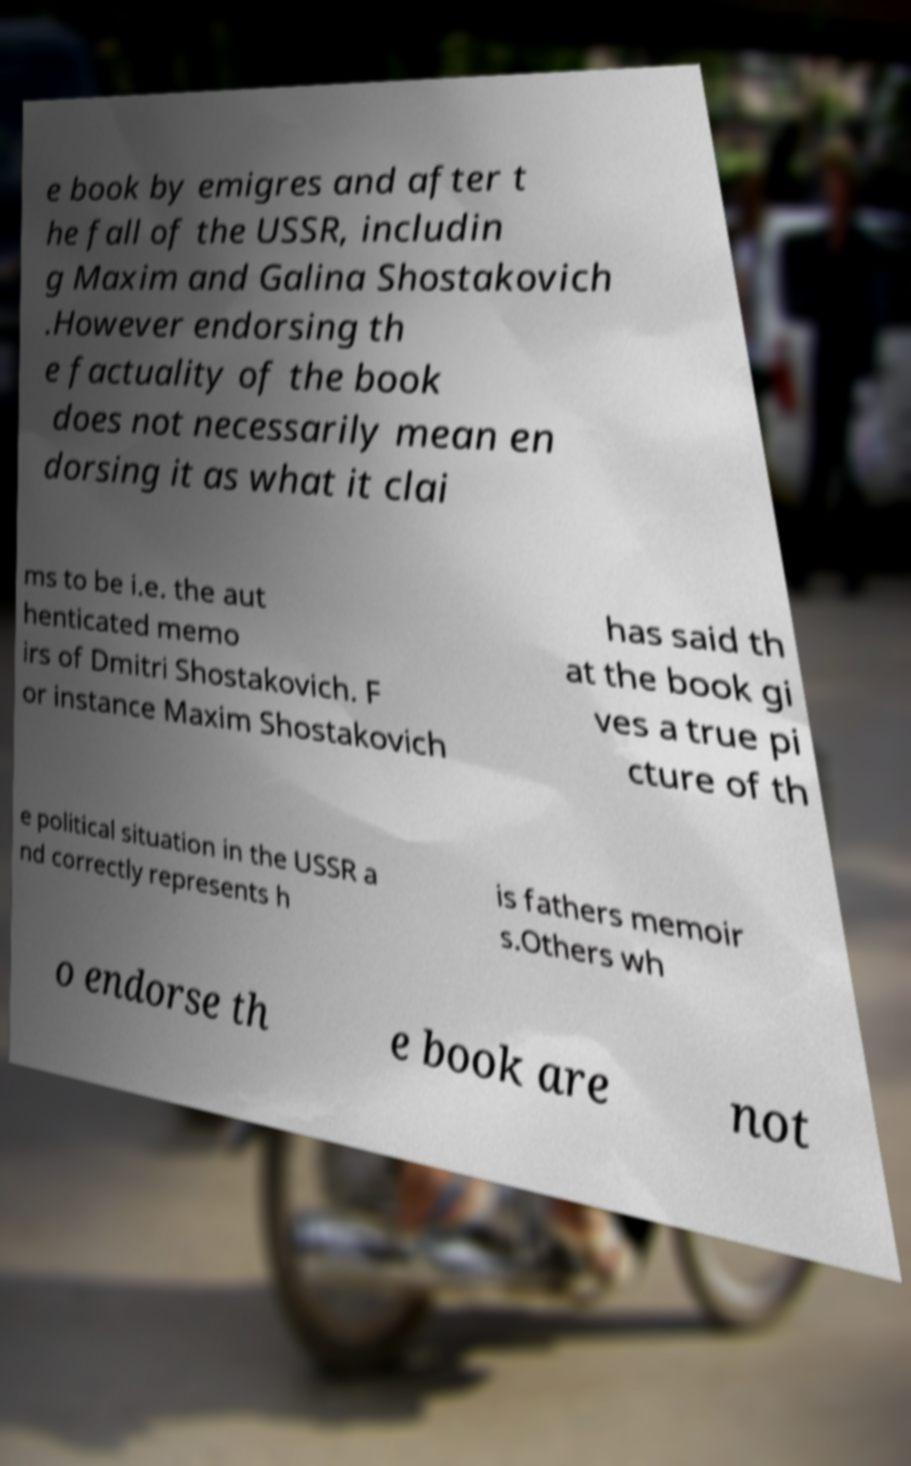Could you extract and type out the text from this image? e book by emigres and after t he fall of the USSR, includin g Maxim and Galina Shostakovich .However endorsing th e factuality of the book does not necessarily mean en dorsing it as what it clai ms to be i.e. the aut henticated memo irs of Dmitri Shostakovich. F or instance Maxim Shostakovich has said th at the book gi ves a true pi cture of th e political situation in the USSR a nd correctly represents h is fathers memoir s.Others wh o endorse th e book are not 